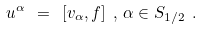<formula> <loc_0><loc_0><loc_500><loc_500>u ^ { \alpha } \ = \ [ v _ { \alpha } , f ] \ , \, \alpha \in S _ { 1 / 2 } \ .</formula> 